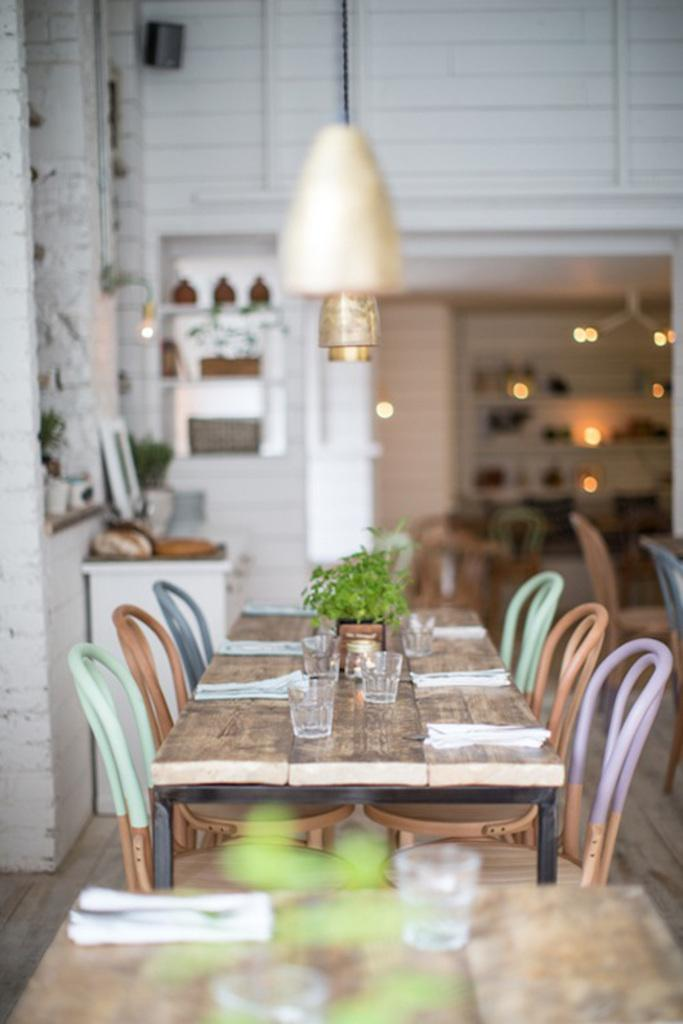What type of furniture is present in the image? There are chairs and a table in the image. What is placed on the table? There are glasses on the table. Are there any decorative elements in the image? Yes, there are flower pots in the image. What can be seen on the shelves in the image? There are objects placed on shelves in the image. What type of group is negotiating a trade in the image? There is no group or trade depicted in the image; it features chairs, a table, glasses, flower pots, and objects on shelves. 